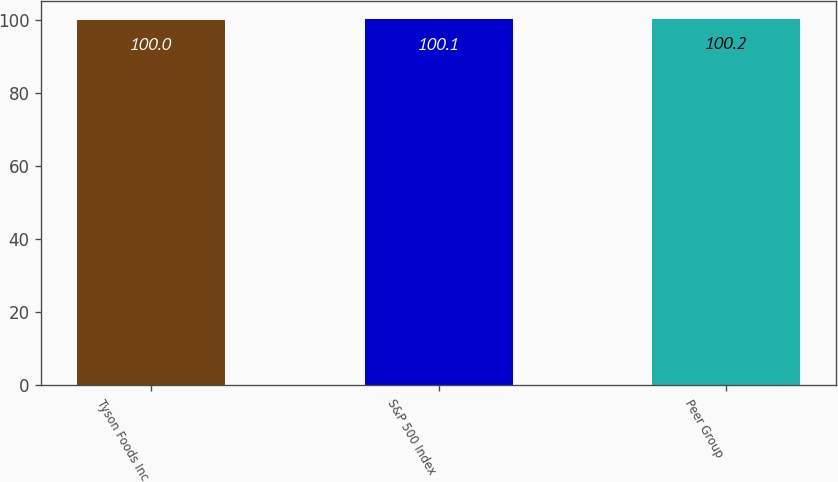Convert chart to OTSL. <chart><loc_0><loc_0><loc_500><loc_500><bar_chart><fcel>Tyson Foods Inc<fcel>S&P 500 Index<fcel>Peer Group<nl><fcel>100<fcel>100.1<fcel>100.2<nl></chart> 